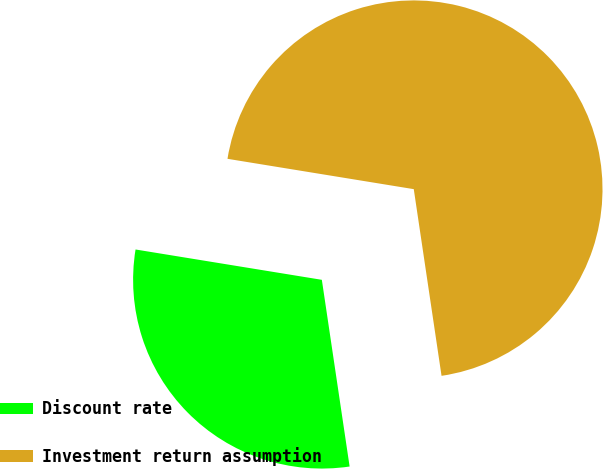Convert chart to OTSL. <chart><loc_0><loc_0><loc_500><loc_500><pie_chart><fcel>Discount rate<fcel>Investment return assumption<nl><fcel>29.92%<fcel>70.08%<nl></chart> 